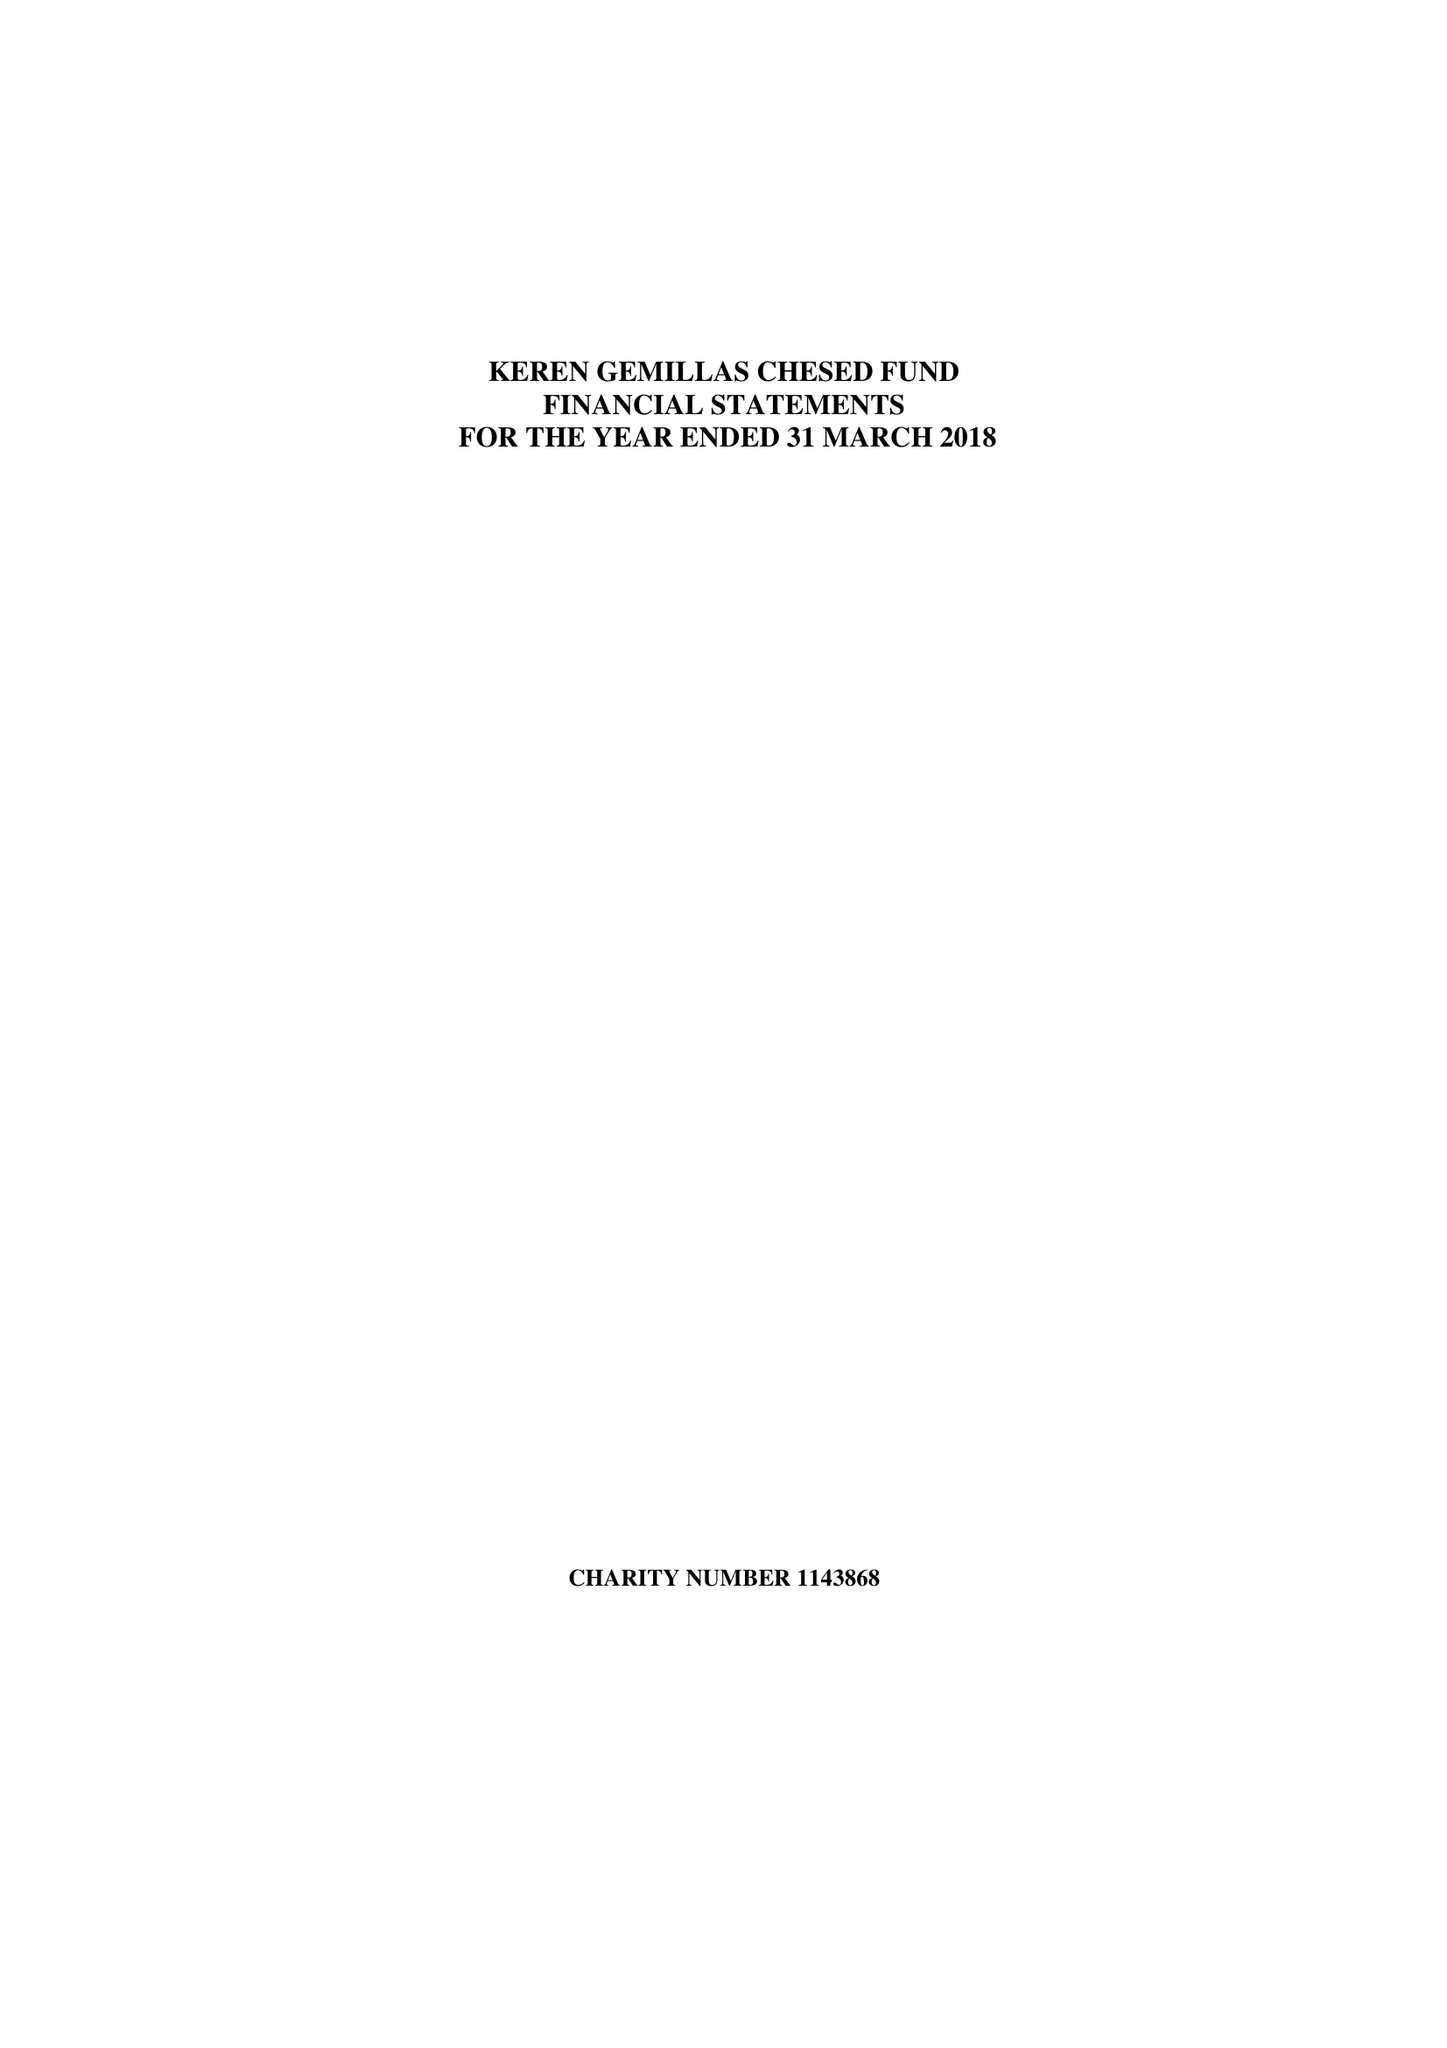What is the value for the charity_number?
Answer the question using a single word or phrase. 1143868 